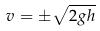<formula> <loc_0><loc_0><loc_500><loc_500>v = \pm \sqrt { 2 g h }</formula> 